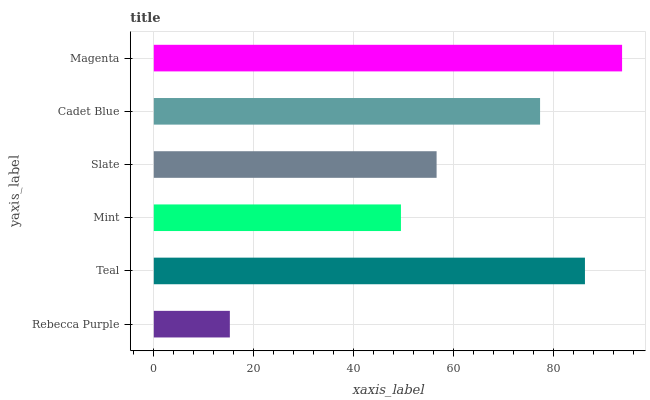Is Rebecca Purple the minimum?
Answer yes or no. Yes. Is Magenta the maximum?
Answer yes or no. Yes. Is Teal the minimum?
Answer yes or no. No. Is Teal the maximum?
Answer yes or no. No. Is Teal greater than Rebecca Purple?
Answer yes or no. Yes. Is Rebecca Purple less than Teal?
Answer yes or no. Yes. Is Rebecca Purple greater than Teal?
Answer yes or no. No. Is Teal less than Rebecca Purple?
Answer yes or no. No. Is Cadet Blue the high median?
Answer yes or no. Yes. Is Slate the low median?
Answer yes or no. Yes. Is Mint the high median?
Answer yes or no. No. Is Mint the low median?
Answer yes or no. No. 